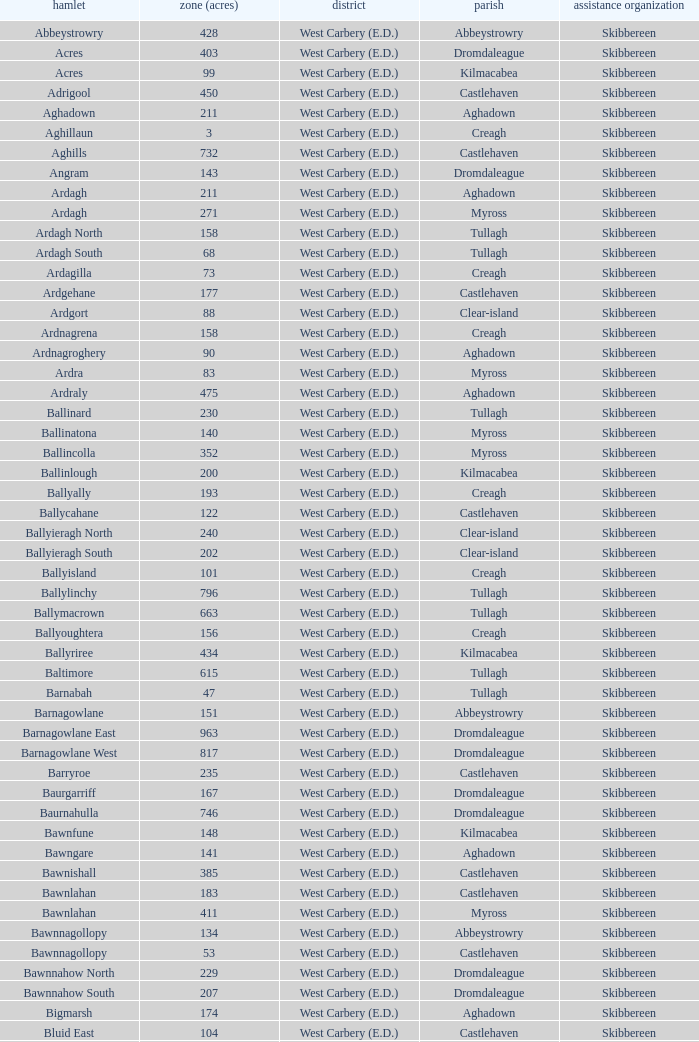What are the civil parishes of the Loughmarsh townland? Aghadown. 